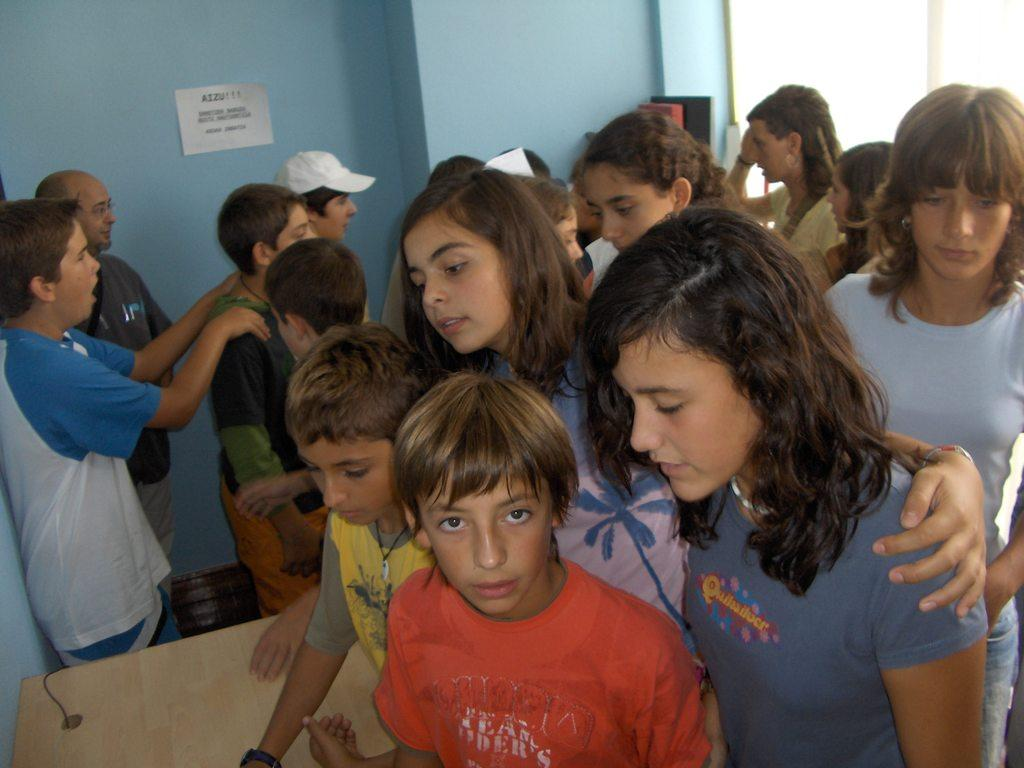How many people are in the group that is visible in the image? There is a group of people standing in the image, but the exact number is not specified. What is the main piece of furniture in the image? There is a table in the image. What can be found on the table? There are objects on the table. What is visible on the wall in the background of the image? There is a paper on the wall in the background of the image. What type of spring is visible on the table in the image? There is no spring present on the table in the image. How does the loss of a loved one affect the group of people in the image? There is no indication of a loss or any emotional state in the image. 